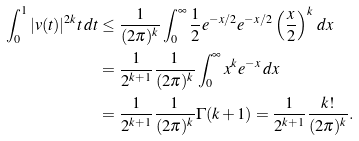Convert formula to latex. <formula><loc_0><loc_0><loc_500><loc_500>\int _ { 0 } ^ { 1 } | v ( t ) | ^ { 2 k } t \, d t & \leq \frac { 1 } { ( 2 \pi ) ^ { k } } \int _ { 0 } ^ { \infty } \frac { 1 } { 2 } e ^ { - x / 2 } e ^ { - x / 2 } \left ( \frac { x } { 2 } \right ) ^ { k } \, d x \\ & = \frac { 1 } { 2 ^ { k + 1 } } \frac { 1 } { ( 2 \pi ) ^ { k } } \int _ { 0 } ^ { \infty } x ^ { k } e ^ { - x } \, d x \\ & = \frac { 1 } { 2 ^ { k + 1 } } \frac { 1 } { ( 2 \pi ) ^ { k } } \Gamma ( k + 1 ) = \frac { 1 } { 2 ^ { k + 1 } } \frac { k ! } { ( 2 \pi ) ^ { k } } .</formula> 